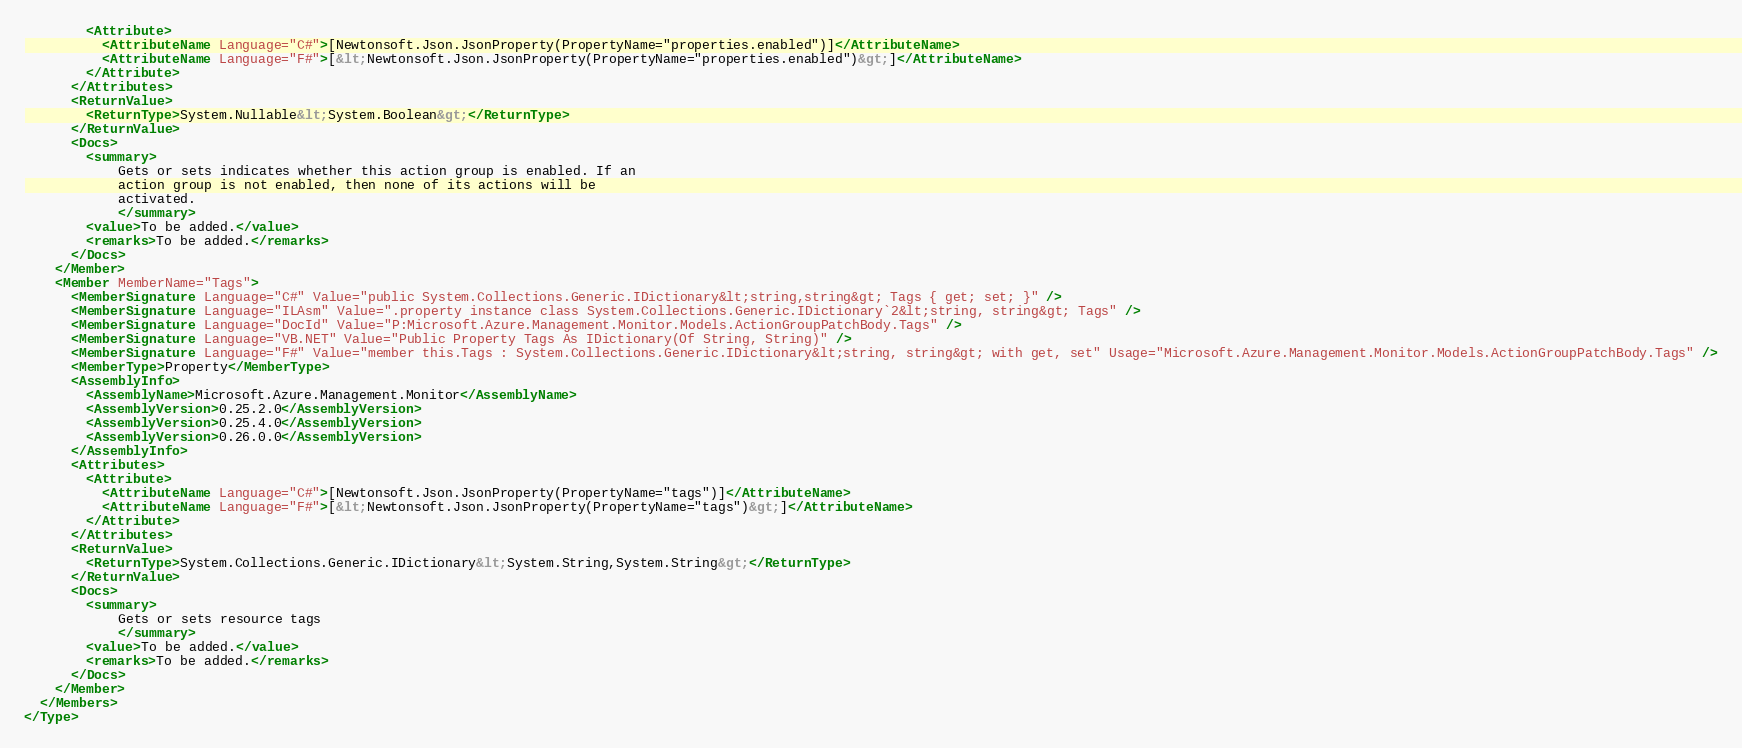Convert code to text. <code><loc_0><loc_0><loc_500><loc_500><_XML_>        <Attribute>
          <AttributeName Language="C#">[Newtonsoft.Json.JsonProperty(PropertyName="properties.enabled")]</AttributeName>
          <AttributeName Language="F#">[&lt;Newtonsoft.Json.JsonProperty(PropertyName="properties.enabled")&gt;]</AttributeName>
        </Attribute>
      </Attributes>
      <ReturnValue>
        <ReturnType>System.Nullable&lt;System.Boolean&gt;</ReturnType>
      </ReturnValue>
      <Docs>
        <summary>
            Gets or sets indicates whether this action group is enabled. If an
            action group is not enabled, then none of its actions will be
            activated.
            </summary>
        <value>To be added.</value>
        <remarks>To be added.</remarks>
      </Docs>
    </Member>
    <Member MemberName="Tags">
      <MemberSignature Language="C#" Value="public System.Collections.Generic.IDictionary&lt;string,string&gt; Tags { get; set; }" />
      <MemberSignature Language="ILAsm" Value=".property instance class System.Collections.Generic.IDictionary`2&lt;string, string&gt; Tags" />
      <MemberSignature Language="DocId" Value="P:Microsoft.Azure.Management.Monitor.Models.ActionGroupPatchBody.Tags" />
      <MemberSignature Language="VB.NET" Value="Public Property Tags As IDictionary(Of String, String)" />
      <MemberSignature Language="F#" Value="member this.Tags : System.Collections.Generic.IDictionary&lt;string, string&gt; with get, set" Usage="Microsoft.Azure.Management.Monitor.Models.ActionGroupPatchBody.Tags" />
      <MemberType>Property</MemberType>
      <AssemblyInfo>
        <AssemblyName>Microsoft.Azure.Management.Monitor</AssemblyName>
        <AssemblyVersion>0.25.2.0</AssemblyVersion>
        <AssemblyVersion>0.25.4.0</AssemblyVersion>
        <AssemblyVersion>0.26.0.0</AssemblyVersion>
      </AssemblyInfo>
      <Attributes>
        <Attribute>
          <AttributeName Language="C#">[Newtonsoft.Json.JsonProperty(PropertyName="tags")]</AttributeName>
          <AttributeName Language="F#">[&lt;Newtonsoft.Json.JsonProperty(PropertyName="tags")&gt;]</AttributeName>
        </Attribute>
      </Attributes>
      <ReturnValue>
        <ReturnType>System.Collections.Generic.IDictionary&lt;System.String,System.String&gt;</ReturnType>
      </ReturnValue>
      <Docs>
        <summary>
            Gets or sets resource tags
            </summary>
        <value>To be added.</value>
        <remarks>To be added.</remarks>
      </Docs>
    </Member>
  </Members>
</Type>
</code> 